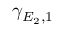Convert formula to latex. <formula><loc_0><loc_0><loc_500><loc_500>\gamma _ { E _ { 2 } , 1 }</formula> 